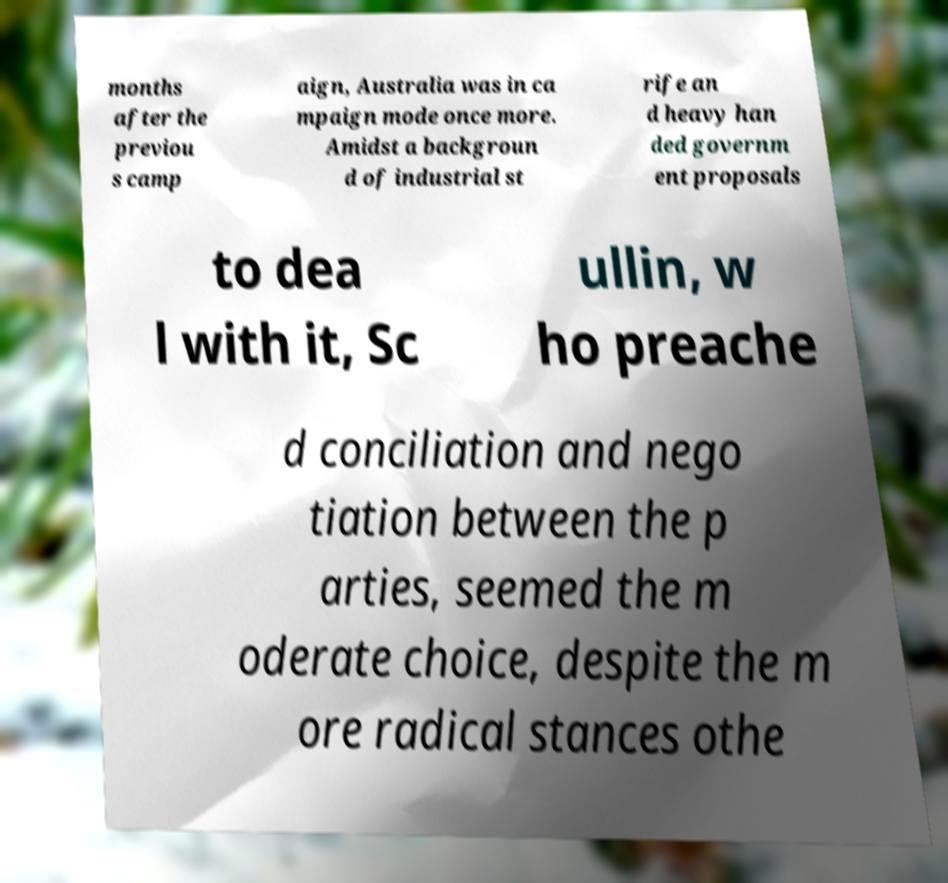Please identify and transcribe the text found in this image. months after the previou s camp aign, Australia was in ca mpaign mode once more. Amidst a backgroun d of industrial st rife an d heavy han ded governm ent proposals to dea l with it, Sc ullin, w ho preache d conciliation and nego tiation between the p arties, seemed the m oderate choice, despite the m ore radical stances othe 